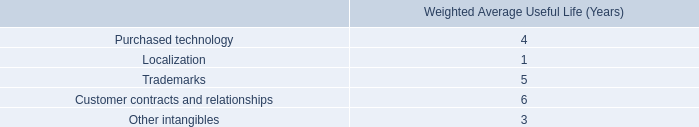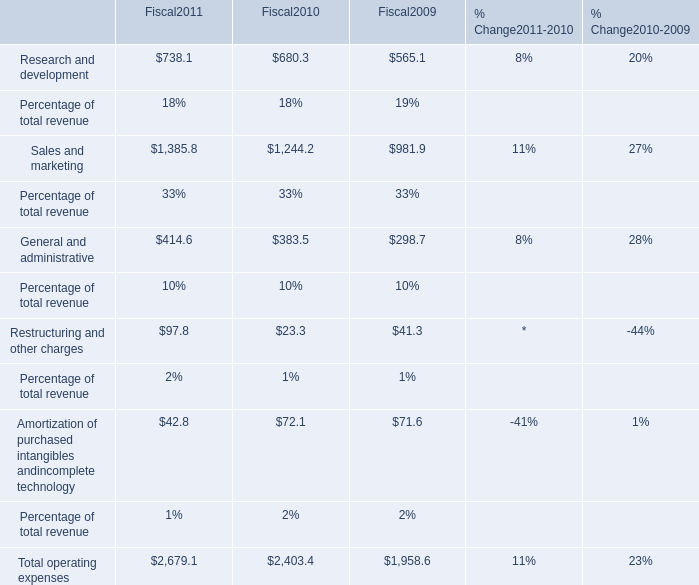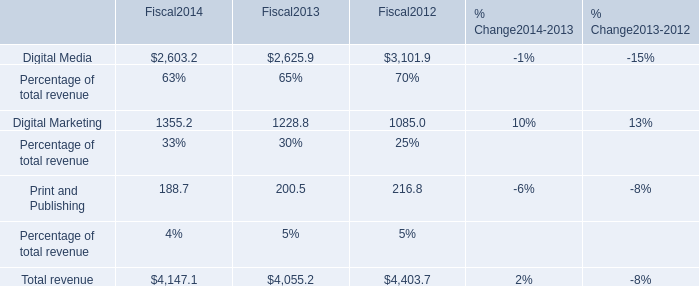what's the total amount of Digital Marketing of Fiscal2013, Sales and marketing of Fiscal2010, and Total operating expenses of Fiscal2011 ? 
Computations: ((1228.8 + 1244.2) + 2679.1)
Answer: 5152.1. 